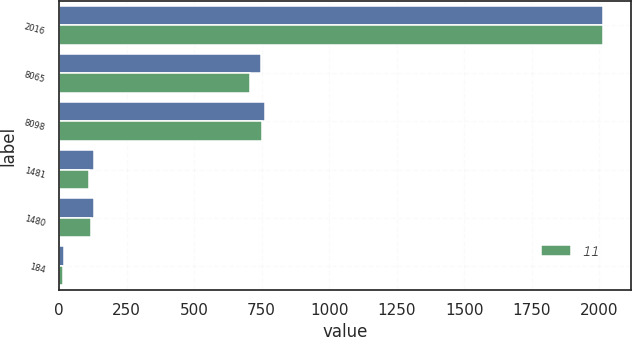Convert chart. <chart><loc_0><loc_0><loc_500><loc_500><stacked_bar_chart><ecel><fcel>2016<fcel>8065<fcel>8098<fcel>1481<fcel>1480<fcel>184<nl><fcel>nan<fcel>2015<fcel>747.1<fcel>763.4<fcel>127.5<fcel>129.3<fcel>17.1<nl><fcel>11<fcel>2014<fcel>705.2<fcel>751.8<fcel>109.9<fcel>116.3<fcel>15.6<nl></chart> 